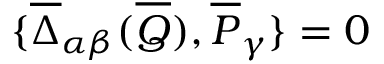Convert formula to latex. <formula><loc_0><loc_0><loc_500><loc_500>\{ \overline { \Delta } _ { \alpha \beta } ( \overline { Q } ) , \overline { P } _ { \gamma } \} = 0</formula> 